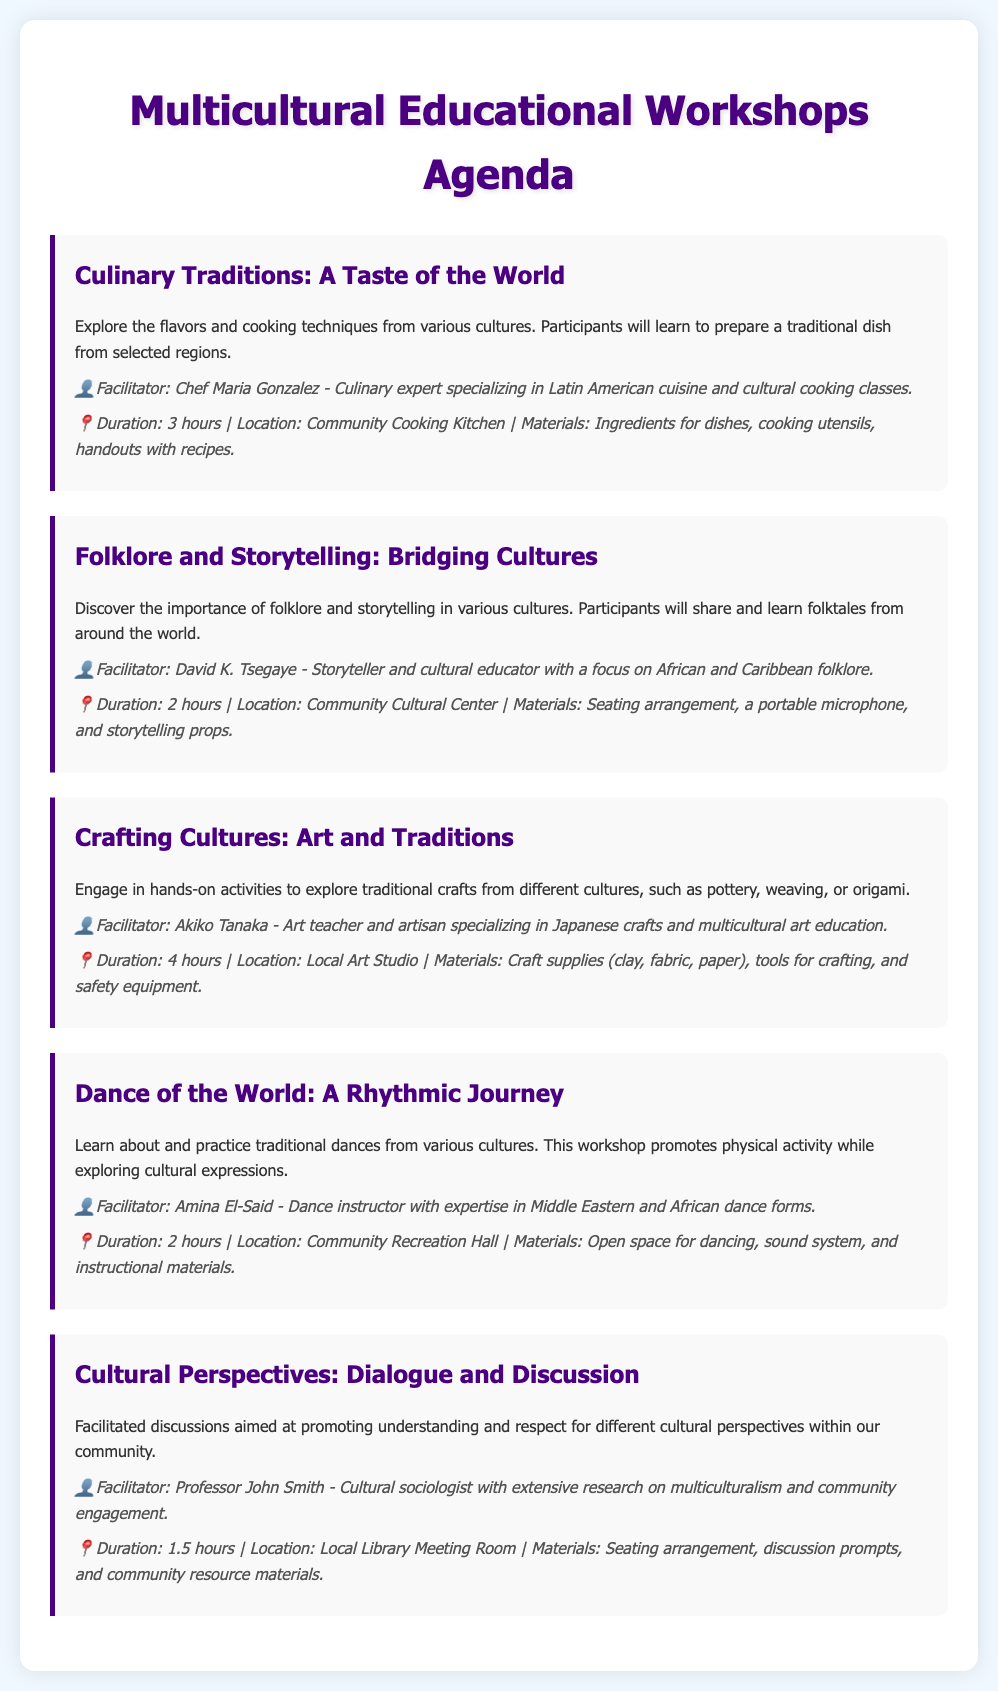What is the title of the first workshop? The title of the first workshop is listed under "Culinary Traditions."
Answer: Culinary Traditions: A Taste of the World Who is the facilitator for the "Crafting Cultures" workshop? The facilitator for the "Crafting Cultures" workshop is mentioned in the description.
Answer: Akiko Tanaka What is the duration of the "Cultural Perspectives" workshop? The duration is provided in the logistics details for the "Cultural Perspectives" workshop.
Answer: 1.5 hours Where will the "Dance of the World" workshop be held? The location is indicated in the logistics section of the workshop description.
Answer: Community Recreation Hall Which workshop focuses on storytelling? The workshop that emphasizes storytelling is defined in the document.
Answer: Folklore and Storytelling: Bridging Cultures What materials are required for the "Culinary Traditions" workshop? The materials are specified in the logistics section of the workshop description.
Answer: Ingredients for dishes, cooking utensils, handouts with recipes How many hours is the "Crafting Cultures" workshop scheduled for? The duration is explicitly noted in the logistics information for the workshop.
Answer: 4 hours Who is the facilitator of the "Cultural Perspectives" workshop? The facilitator's name is provided within the workshop's description.
Answer: Professor John Smith 